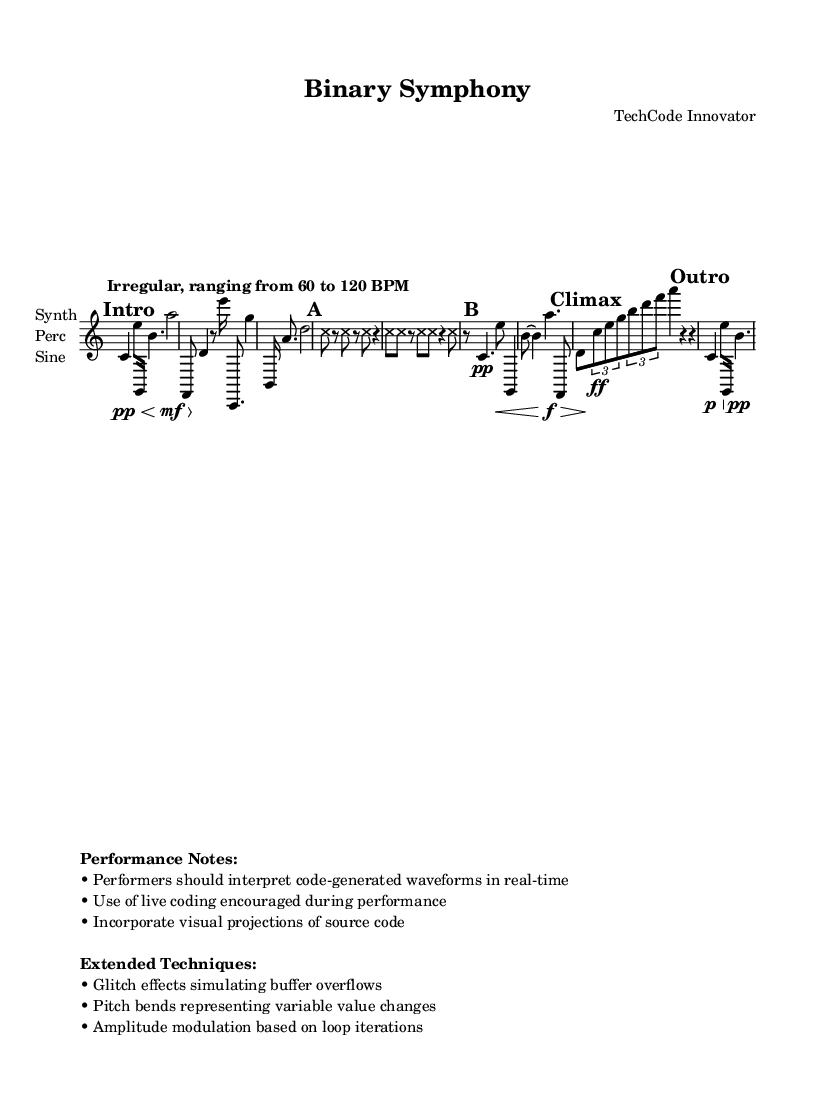What is the time signature for the first section of the piece? The first section, labeled "Intro," has a time signature of 5/4, which can be identified right after the mark.
Answer: 5/4 What tempo indication is provided for the piece? The tempo indication states "Irregular, ranging from 60 to 120 BPM," which describes the range of beats per minute for performance.
Answer: Irregular, ranging from 60 to 120 BPM How many measures are there in Section A? Section A consists of 4 measures, indicated by the notation and the grouping of notes within the provided time signature of 4/4.
Answer: 4 What extended technique involves simulating buffer overflows? The piece mentions "Glitch effects simulating buffer overflows" as part of its extended techniques, making this a specific type of sound manipulation used.
Answer: Glitch effects What is the dynamic marking for the 'Climax' section? The Climax section includes a dynamic marking of "ff," which stands for fortissimo, indicating a very loud performance level.
Answer: ff In what time signature does the 'Outro' section occur? The Outro section is marked with a time signature of 3/4, which can be found at the beginning of its notation.
Answer: 3/4 How many instruments are indicated in the score? The score indicates three instruments under the staff as "Synth," "Perc," and "Sine," showing the different musical parts to be played.
Answer: 3 